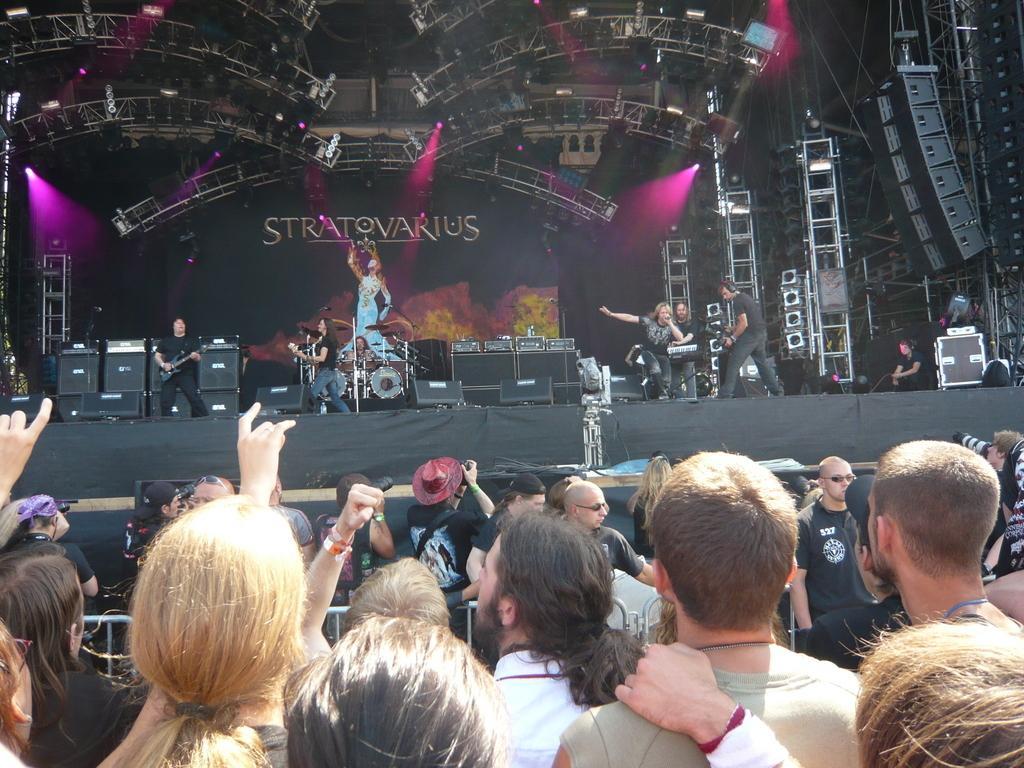Please provide a concise description of this image. In this picture we can see some people are performing on the stage, a person on the left side is playing a guitar, we can see musical instruments and some some boxes present on the stage, there are some people at the bottom, in the background we can see some metal rods and lights. 